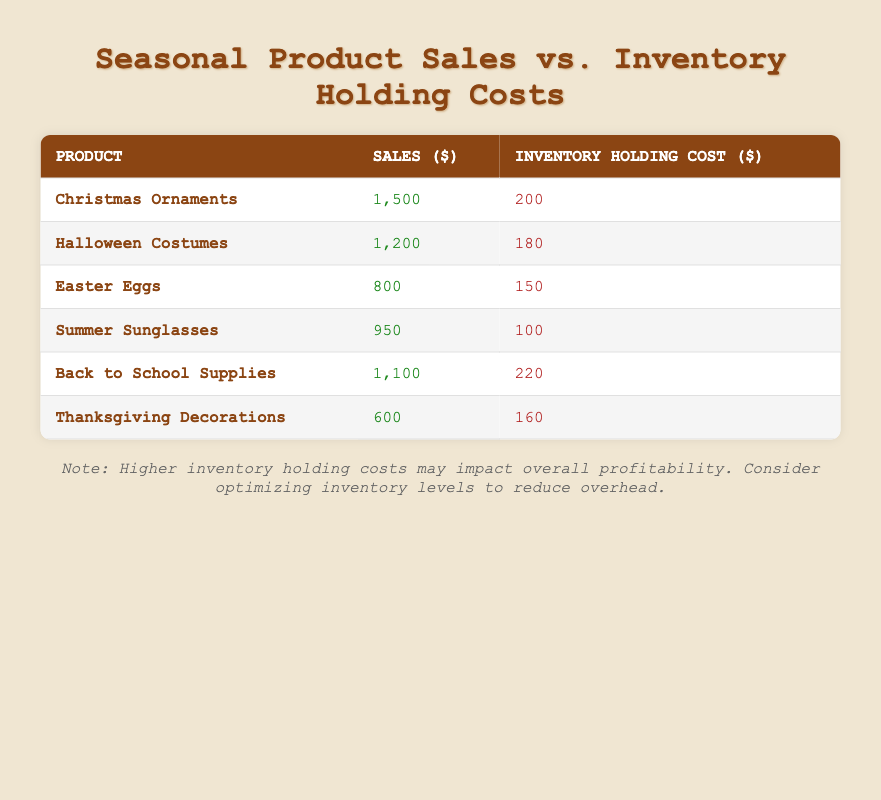What is the sales figure for Halloween Costumes? According to the table, the sales figure for Halloween Costumes is found in the sales column corresponding to that product row. This value is directly listed as 1,200.
Answer: 1,200 What is the inventory holding cost for Easter Eggs? The table shows the inventory holding cost for Easter Eggs, which is listed in the cost column corresponding to that product row. The value given is 150.
Answer: 150 Which product has the highest sales? By comparing the sales figures listed in the sales column for each product, it is determined that Christmas Ornaments have the highest sales at 1,500.
Answer: Christmas Ornaments What is the total sales amount for all products in the table? To find the total sales, you would sum up each of the sales values: 1,500 + 1,200 + 800 + 950 + 1,100 + 600 = 5,150.
Answer: 5,150 Is the inventory holding cost for Summer Sunglasses higher than for Halloween Costumes? Looking at the inventory holding costs for both products, Summer Sunglasses have a cost of 100, while Halloween Costumes have a cost of 180. Therefore, 100 is not higher than 180, making this statement false.
Answer: No Which product has the lowest inventory holding cost? To find the product with the lowest inventory holding cost, compare all the values in the cost column. The lowest cost is for Summer Sunglasses at 100.
Answer: Summer Sunglasses What is the average inventory holding cost for all products? The average holding cost is calculated by summing the inventory holding costs: 200 + 180 + 150 + 100 + 220 + 160 = 1,110. Then, divide by the number of products (6): 1,110 / 6 = 185.
Answer: 185 Is it true that all products with higher sales also have higher inventory holding costs? We need to examine if higher sales correspond with higher holding costs. For example, Christmas Ornaments have high sales but a cost of 200, while Easter Eggs have lower sales at 800 but a lower cost of 150, indicating that higher sales do not consistently correlate with higher costs. Thus, the statement is false.
Answer: No What is the difference in sales between Back to School Supplies and Thanksgiving Decorations? The sales figure for Back to School Supplies is 1,100 and for Thanksgiving Decorations is 600. The difference is calculated as 1,100 - 600 = 500.
Answer: 500 